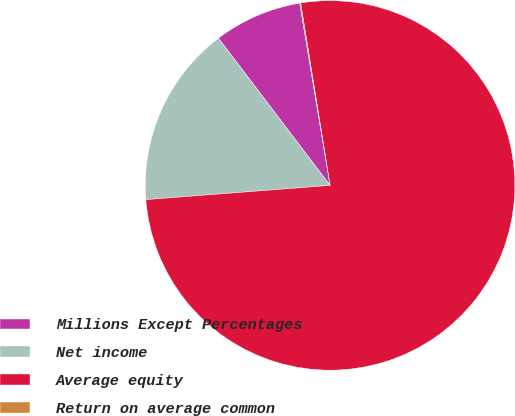<chart> <loc_0><loc_0><loc_500><loc_500><pie_chart><fcel>Millions Except Percentages<fcel>Net income<fcel>Average equity<fcel>Return on average common<nl><fcel>7.7%<fcel>15.9%<fcel>76.32%<fcel>0.08%<nl></chart> 